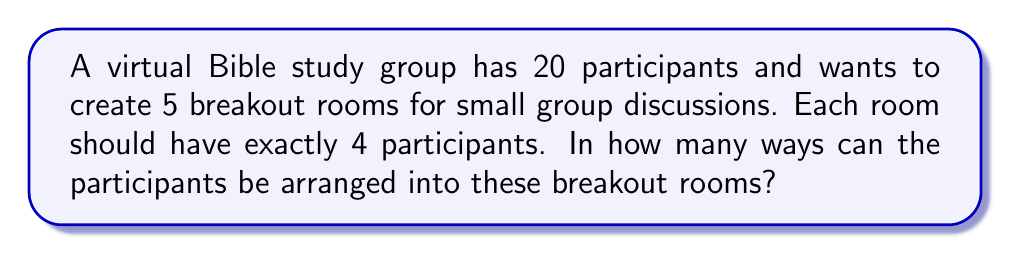Help me with this question. To solve this problem, we can use the concept of dividing a set into subsets, which is a type of partition problem. Here's how we can approach it:

1) First, we need to choose 4 participants for the first room. This can be done in $\binom{20}{4}$ ways.

2) For the second room, we choose 4 participants from the remaining 16. This can be done in $\binom{16}{4}$ ways.

3) We continue this process for the third and fourth rooms, choosing from the remaining participants each time.

4) For the last room, we don't need to make a choice as the remaining 4 participants will automatically form the fifth room.

5) The total number of ways to arrange the participants is the product of these choices:

   $$\binom{20}{4} \cdot \binom{16}{4} \cdot \binom{12}{4} \cdot \binom{8}{4}$$

6) We can calculate this:
   $$\frac{20!}{4!(20-4)!} \cdot \frac{16!}{4!(16-4)!} \cdot \frac{12!}{4!(12-4)!} \cdot \frac{8!}{4!(8-4)!}$$

   $$= \frac{20!}{4!16!} \cdot \frac{16!}{4!12!} \cdot \frac{12!}{4!8!} \cdot \frac{8!}{4!4!}$$

   $$= \frac{20!}{(4!)^5 \cdot 4!}$$

7) Calculating this gives us 11,631,937,500 ways.

However, this counts arrangements where the order of the rooms matters. If the order of the rooms doesn't matter (which is typically the case in virtual breakout rooms), we need to divide by 5! to account for the number of ways to arrange the 5 rooms:

$$\frac{11,631,937,500}{5!} = 303,963,750$$
Answer: There are 303,963,750 ways to arrange the 20 Bible study participants into 5 virtual breakout rooms of 4 participants each. 